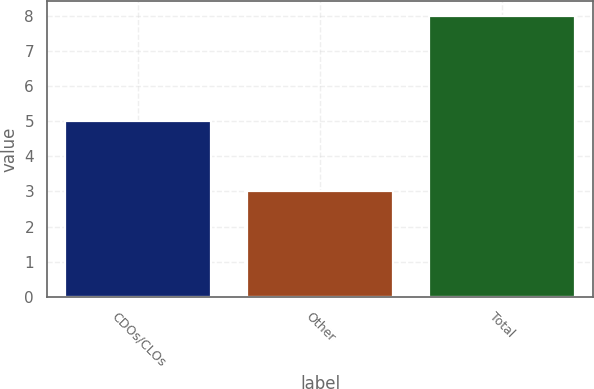<chart> <loc_0><loc_0><loc_500><loc_500><bar_chart><fcel>CDOs/CLOs<fcel>Other<fcel>Total<nl><fcel>5<fcel>3<fcel>8<nl></chart> 